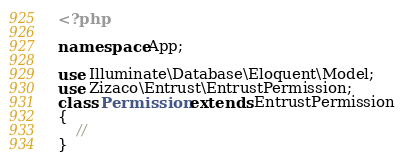<code> <loc_0><loc_0><loc_500><loc_500><_PHP_><?php

namespace App;

use Illuminate\Database\Eloquent\Model;
use Zizaco\Entrust\EntrustPermission;
class Permission extends EntrustPermission
{
    //
}
</code> 